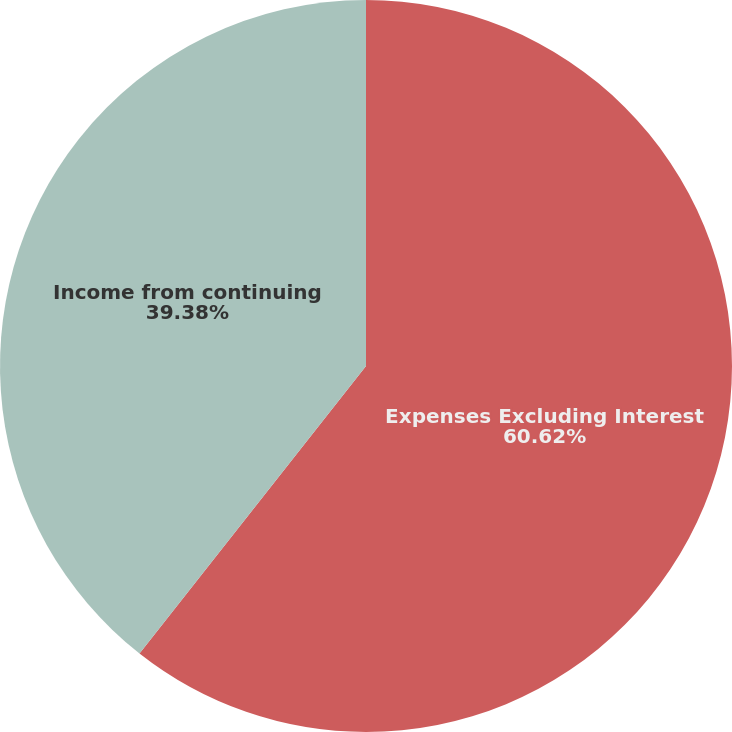Convert chart to OTSL. <chart><loc_0><loc_0><loc_500><loc_500><pie_chart><fcel>Expenses Excluding Interest<fcel>Income from continuing<nl><fcel>60.62%<fcel>39.38%<nl></chart> 